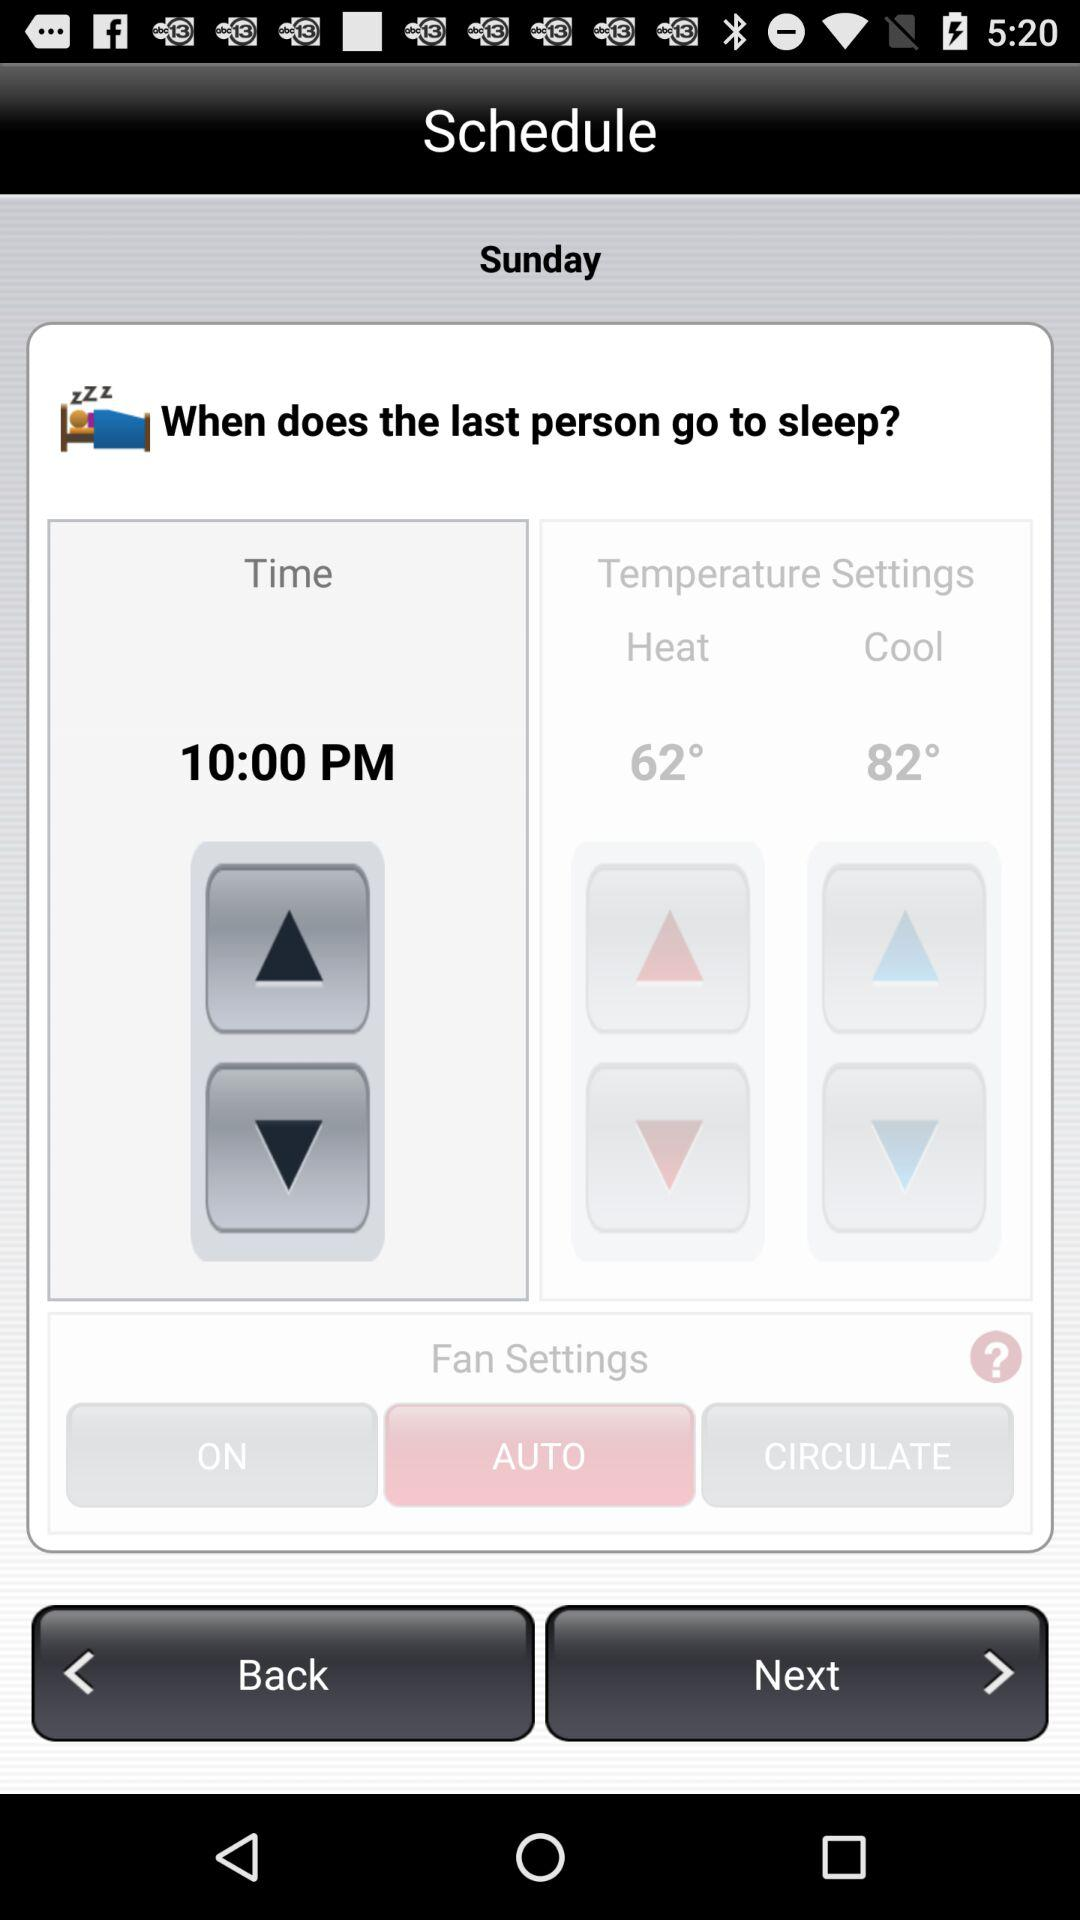What is the status of fan settings? The status is auto. 